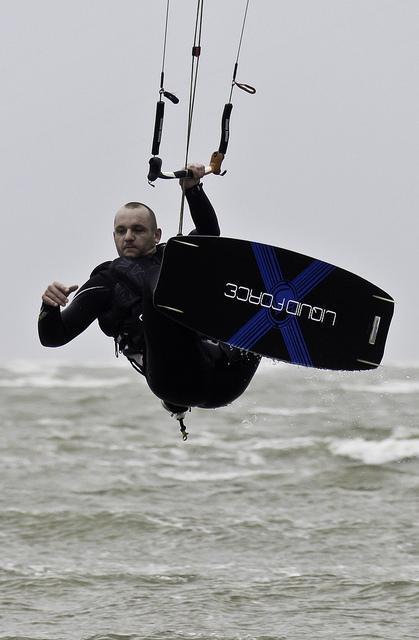How many boxes of pizza are there?
Give a very brief answer. 0. 